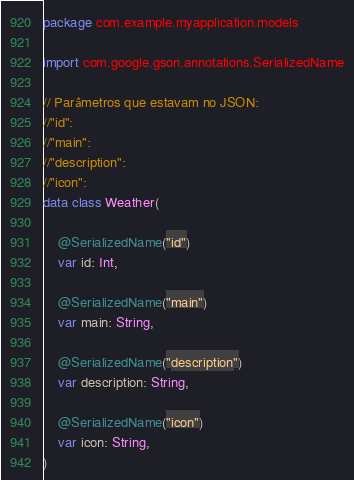Convert code to text. <code><loc_0><loc_0><loc_500><loc_500><_Kotlin_>package com.example.myapplication.models

import com.google.gson.annotations.SerializedName

// Parâmetros que estavam no JSON:
//"id":
//"main":
//"description":
//"icon":
data class Weather(

    @SerializedName("id")
    var id: Int,

    @SerializedName("main")
    var main: String,

    @SerializedName("description")
    var description: String,

    @SerializedName("icon")
    var icon: String,
)
</code> 